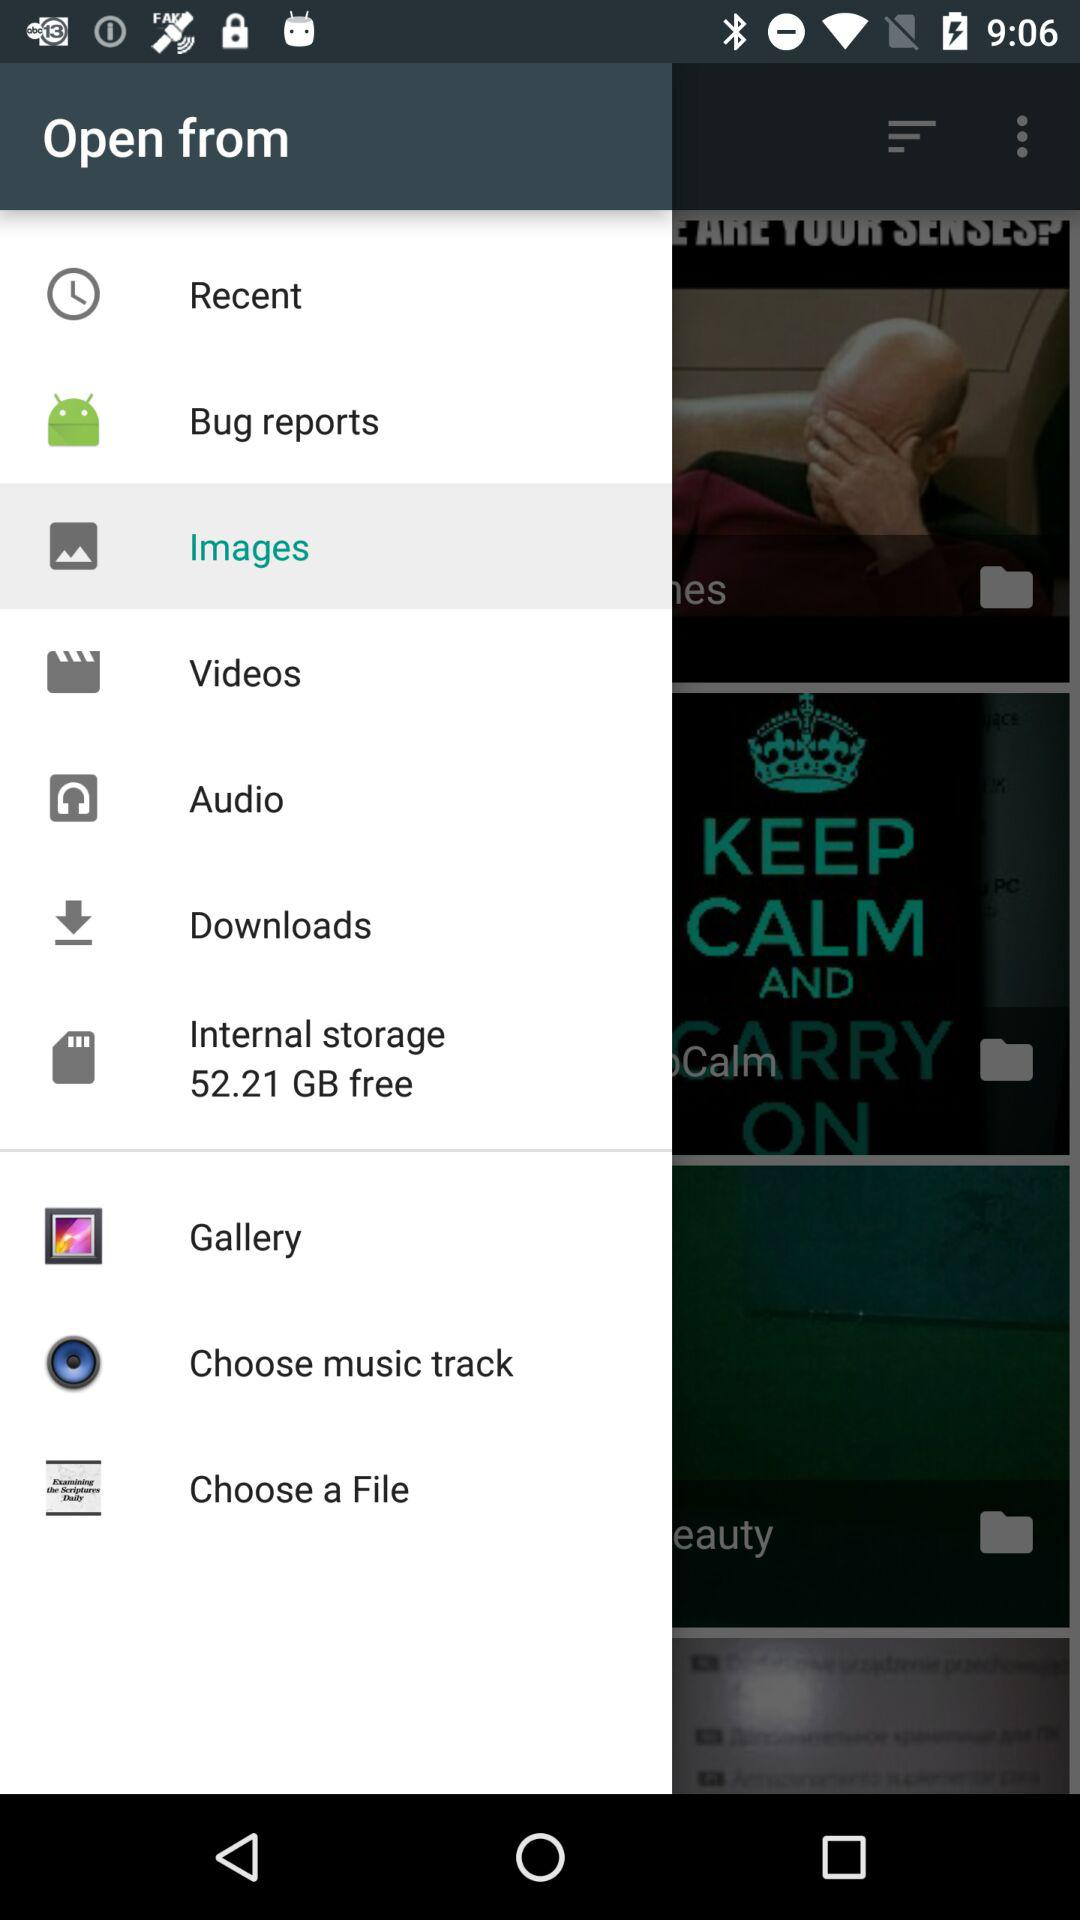How much internal storage is free? The free internal storage is 52.21 GB. 